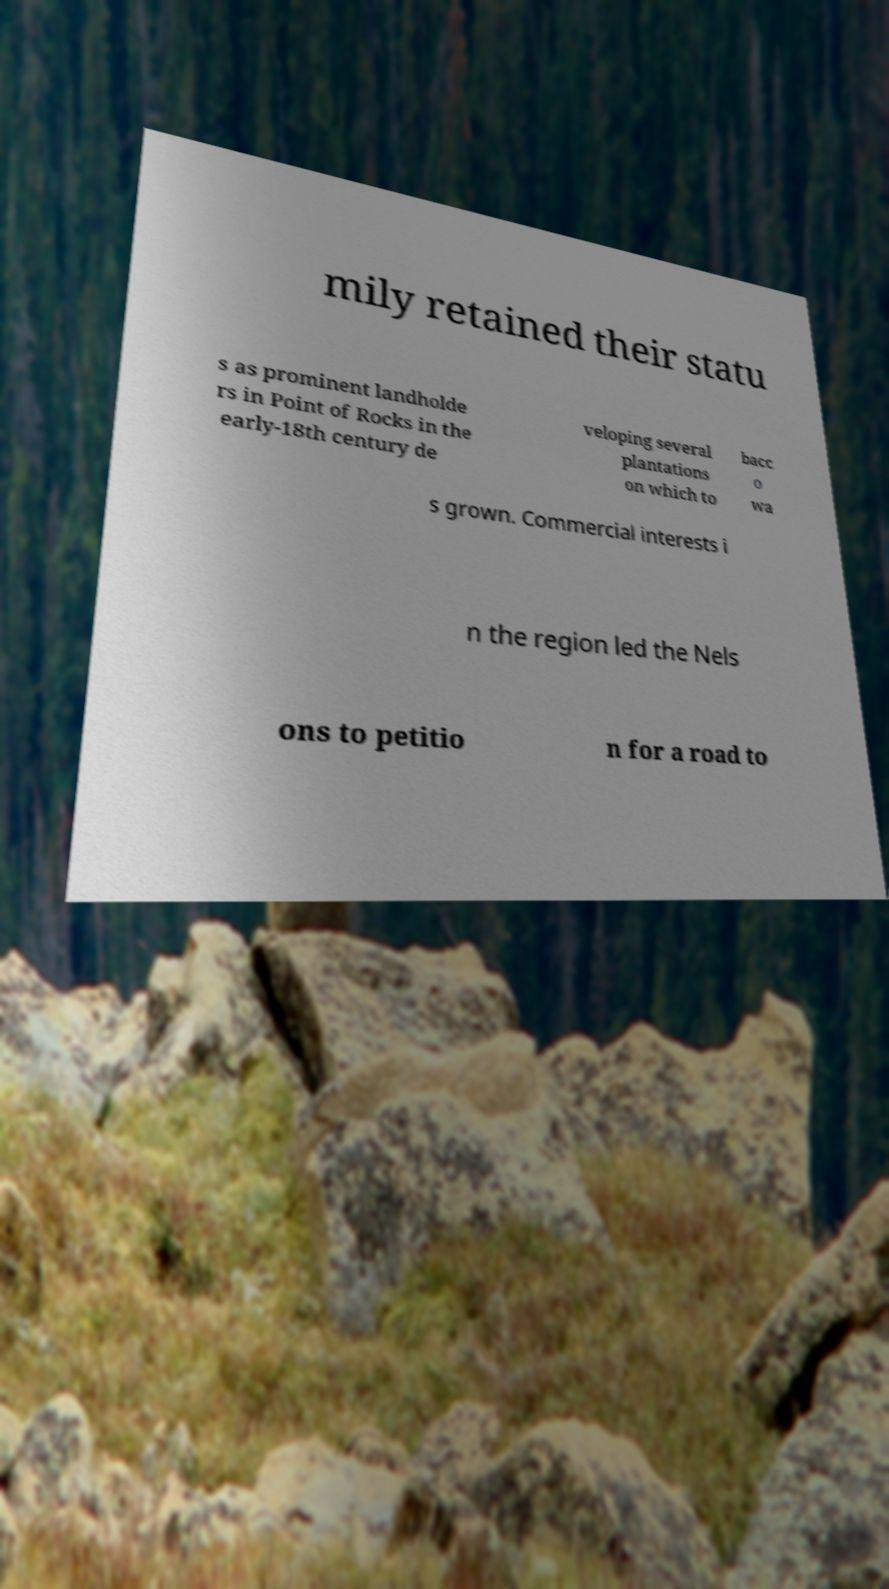What messages or text are displayed in this image? I need them in a readable, typed format. mily retained their statu s as prominent landholde rs in Point of Rocks in the early-18th century de veloping several plantations on which to bacc o wa s grown. Commercial interests i n the region led the Nels ons to petitio n for a road to 